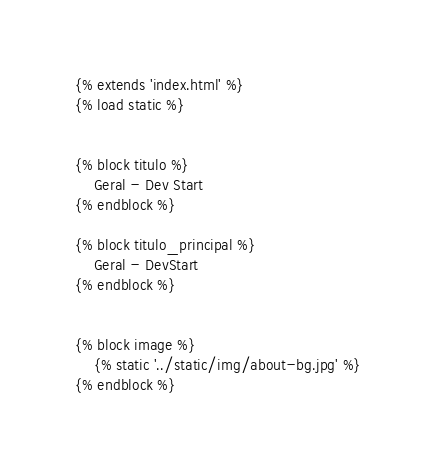<code> <loc_0><loc_0><loc_500><loc_500><_HTML_>{% extends 'index.html' %}
{% load static %}


{% block titulo %}
    Geral - Dev Start
{% endblock %}

{% block titulo_principal %}
    Geral - DevStart
{% endblock %}


{% block image %}
    {% static '../static/img/about-bg.jpg' %}
{% endblock %}</code> 